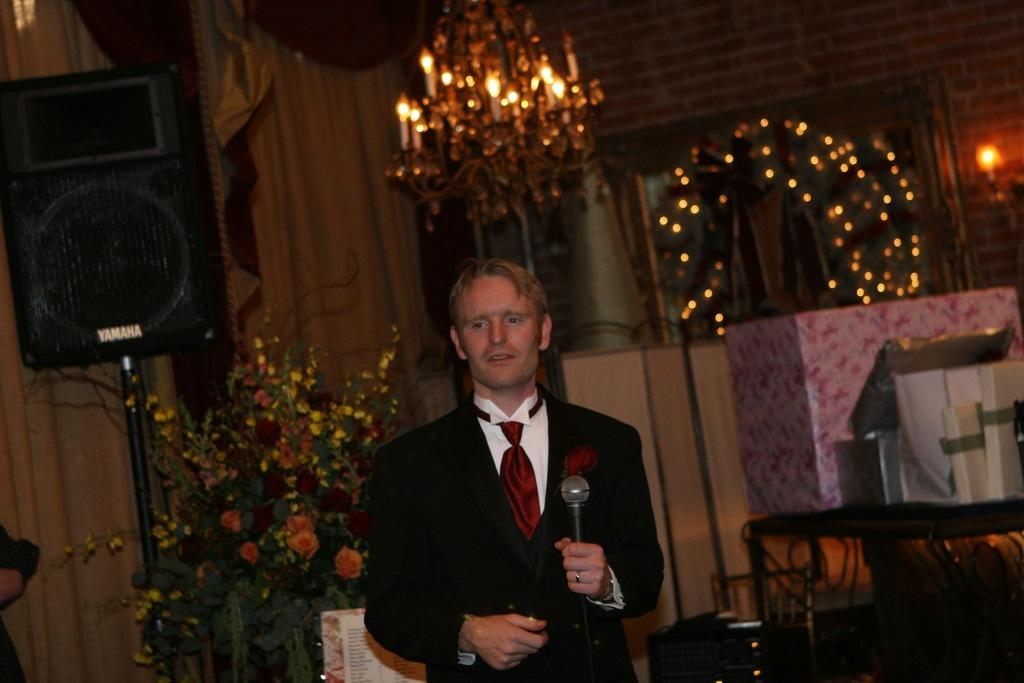What is the person in the foreground of the image holding? The person is holding a microphone in the foreground of the image. What can be seen in addition to the person with the microphone? There are flowers visible in the image. What object related to sound can be seen in the image? There is a sound box in the image. What type of background is present in the image? There is a brick wall in the background of the image. Can you see any visible veins in the flowers in the image? There is no mention of veins in the flowers in the image, and veins are not visible in flowers. 